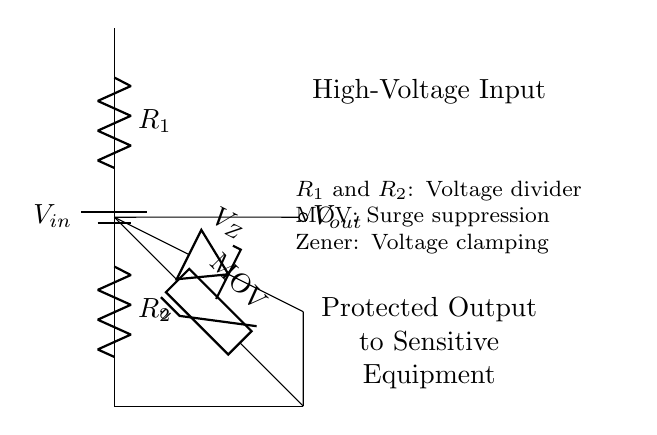What is the input voltage in this circuit? The input voltage is defined as \( V_{in} \) in the diagram, typically representing the source voltage connected to the circuit.
Answer: \( V_{in} \) What type of surge protection is used in this circuit? The surge protection is provided by a Metal-Oxide Varistor (MOV), which is used to clamp transient voltages and protect sensitive components in the circuit from surges.
Answer: MOV What are the resistances in the voltage divider? The resistances in the voltage divider are labeled as \( R_1 \) and \( R_2 \). These components determine the division of the input voltage to create a lower output voltage suitable for the sensitive equipment.
Answer: \( R_1 \), \( R_2 \) How does the Zener diode function in this circuit? The Zener diode, labeled \( V_Z \), functions by allowing current to flow in the reverse direction when the voltage exceeds a certain threshold, effectively clamping the output voltage to a safe level for sensitive equipment.
Answer: Clamps voltage What is the output voltage of this voltage divider? The output voltage \( V_{out} \) results from the voltage division formula based on the resistances \( R_1 \) and \( R_2 \), but the exact value is indeterminate without specific resistance values; it's a function of the input voltage and resistances.
Answer: \( V_{out} \) Which components are used to protect the output? The components used to protect the output are the MOV for surge suppression and the Zener diode for voltage clamping, ensuring safe operation for sensitive control equipment.
Answer: MOV, Zener diode 